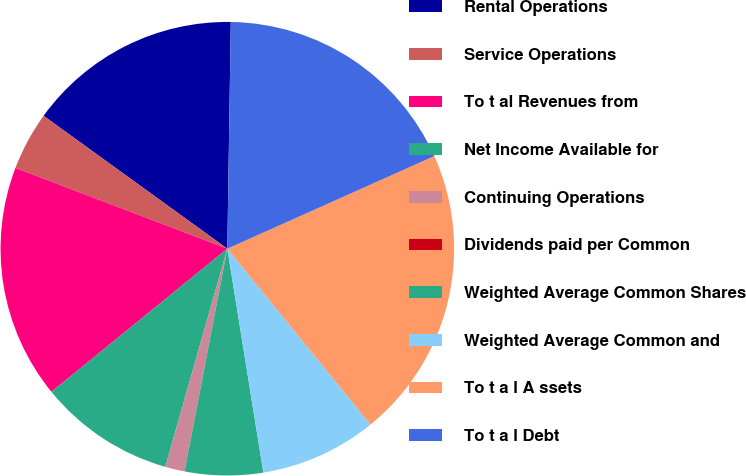Convert chart to OTSL. <chart><loc_0><loc_0><loc_500><loc_500><pie_chart><fcel>Rental Operations<fcel>Service Operations<fcel>To t al Revenues from<fcel>Net Income Available for<fcel>Continuing Operations<fcel>Dividends paid per Common<fcel>Weighted Average Common Shares<fcel>Weighted Average Common and<fcel>To t a l A ssets<fcel>To t a l Debt<nl><fcel>15.28%<fcel>4.17%<fcel>16.67%<fcel>9.72%<fcel>1.39%<fcel>0.0%<fcel>5.56%<fcel>8.33%<fcel>20.83%<fcel>18.06%<nl></chart> 